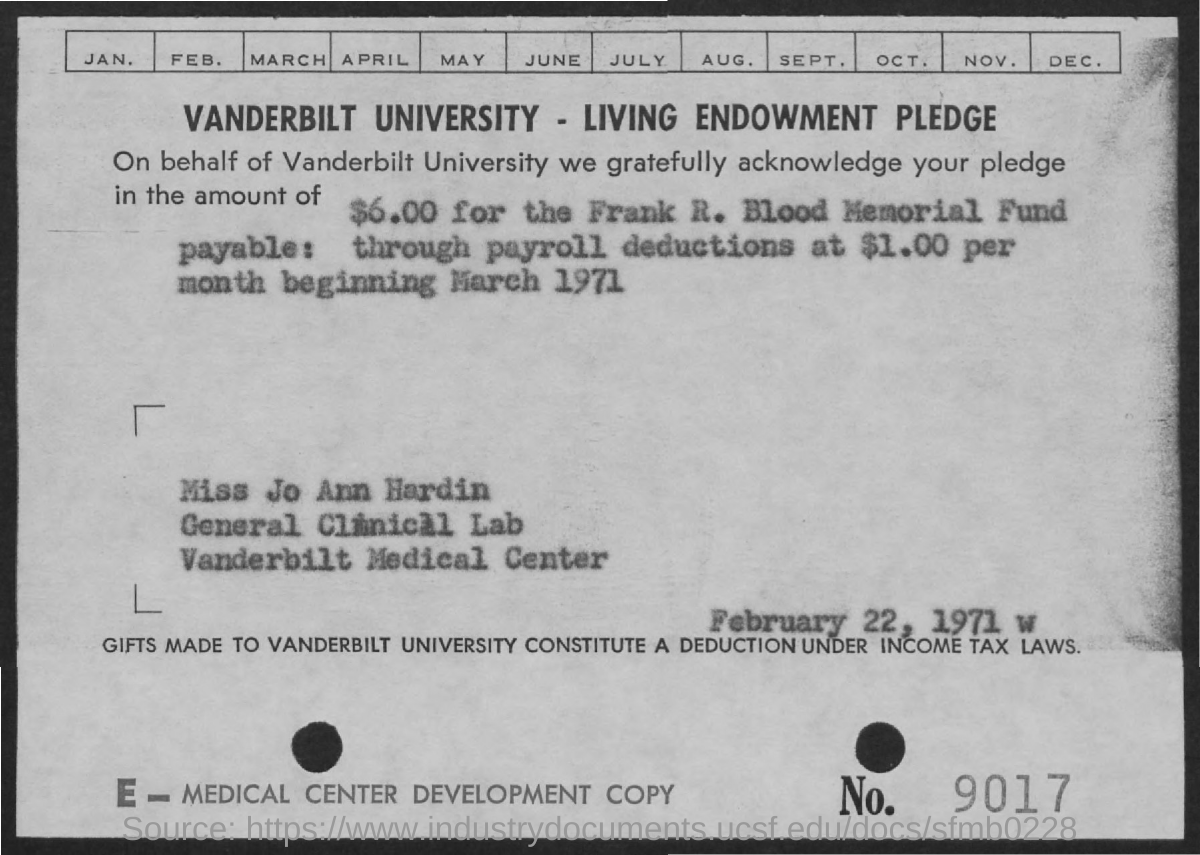What is the university name?
Keep it short and to the point. Vanderbilt university. For what amount is the pledge acknowledged?
Your answer should be compact. $6.00. How much is the payroll deduction per month?
Ensure brevity in your answer.  $1.00. Gifts made to vanderbilt university constitute a deduction under which laws?
Give a very brief answer. Income tax laws. What is the no. mentioned in the bottom right corner?
Provide a short and direct response. 9017. What is the date mentioned?
Ensure brevity in your answer.  February 22, 1971. For what is the amount pledged for?
Your response must be concise. Frank R. Blood memorial fund. 